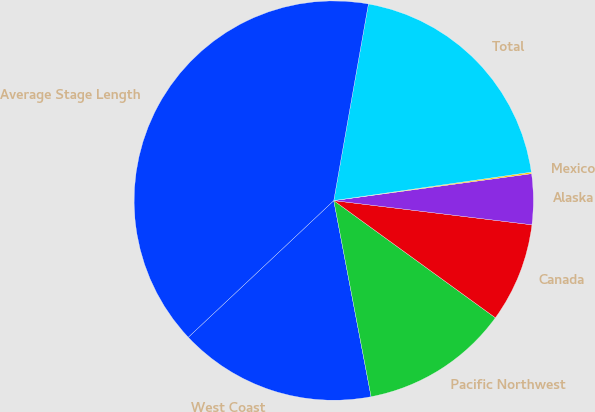Convert chart to OTSL. <chart><loc_0><loc_0><loc_500><loc_500><pie_chart><fcel>West Coast<fcel>Pacific Northwest<fcel>Canada<fcel>Alaska<fcel>Mexico<fcel>Total<fcel>Average Stage Length<nl><fcel>15.99%<fcel>12.02%<fcel>8.05%<fcel>4.09%<fcel>0.12%<fcel>19.95%<fcel>39.78%<nl></chart> 